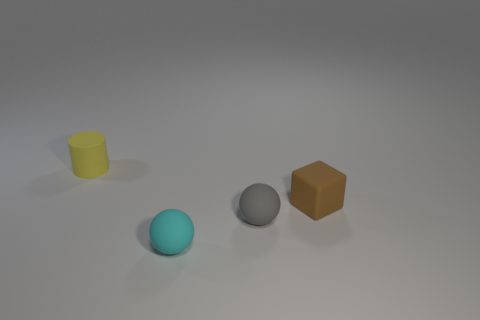Add 2 balls. How many objects exist? 6 Subtract all cylinders. How many objects are left? 3 Subtract 0 gray blocks. How many objects are left? 4 Subtract all gray rubber spheres. Subtract all tiny yellow matte cylinders. How many objects are left? 2 Add 2 yellow things. How many yellow things are left? 3 Add 1 tiny matte balls. How many tiny matte balls exist? 3 